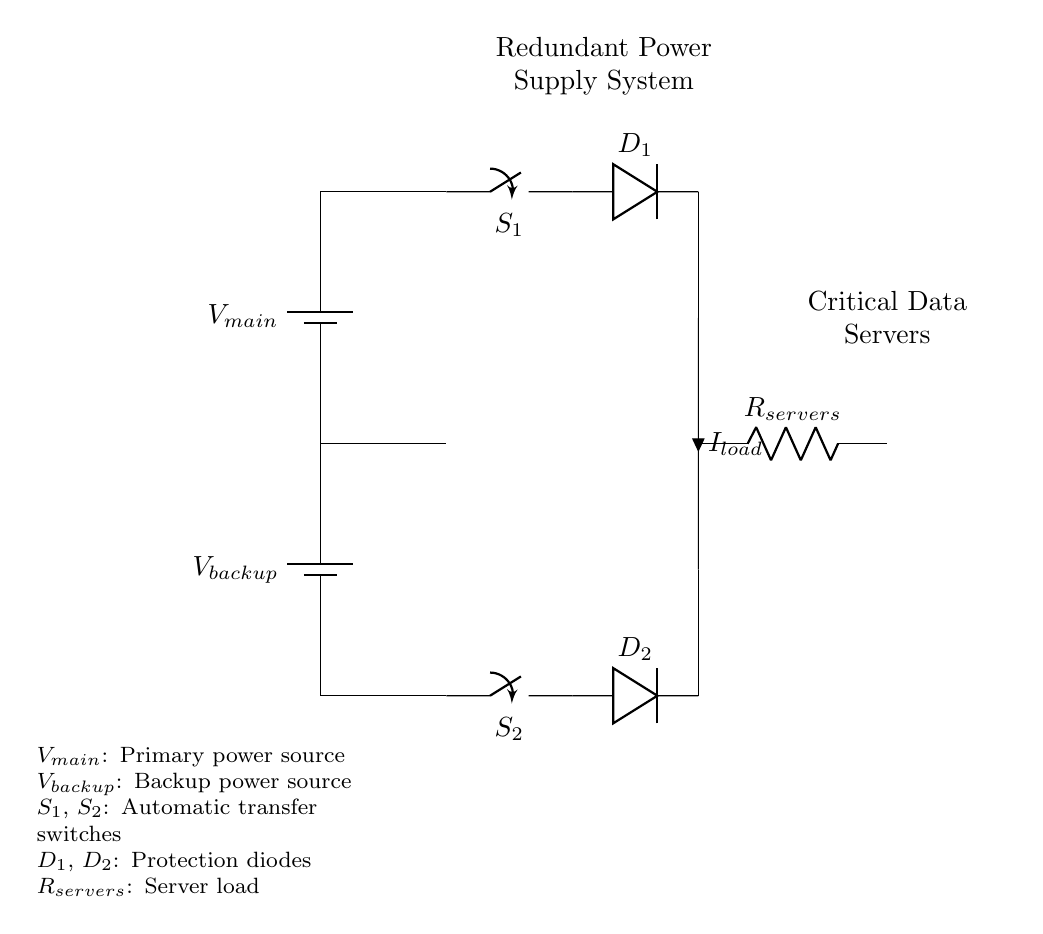What are the two sources of power in this circuit? The circuit diagram shows two power sources: the main power source labeled as V main and the backup power source labeled as V backup.
Answer: V main, V backup What type of switches are used in this circuit? The circuit includes two automatic transfer switches labeled as S1 and S2, which switch between the two power supplies based on availability.
Answer: Automatic transfer switches How many diodes are in this circuit? There are two diodes present in the circuit, marked as D1 and D2, which serve to protect the circuit by allowing current to flow in one direction only.
Answer: 2 What is the purpose of the load in this circuit? The load in the circuit is represented by the resistor labeled as R servers, which represents the critical data servers that require power from the redundant supply system.
Answer: Critical data servers What happens when both V main and V backup are available? When both power sources are available, the automatic transfer switches (S1 and S2) ensure that the load receives power from V main, while V backup remains on standby to take over if needed.
Answer: V main supplies the load What is the importance of the protection diodes? The diodes (D1 and D2) provide protection by preventing backflow of current, ensuring that if one power source fails, the other can take over without damaging the circuit.
Answer: Prevent backflow of current If V main fails, what will happen to the load? If V main fails, S1 and S2 will automatically switch to V backup, ensuring that the load continues to receive power without interruption.
Answer: Load continues to receive power 